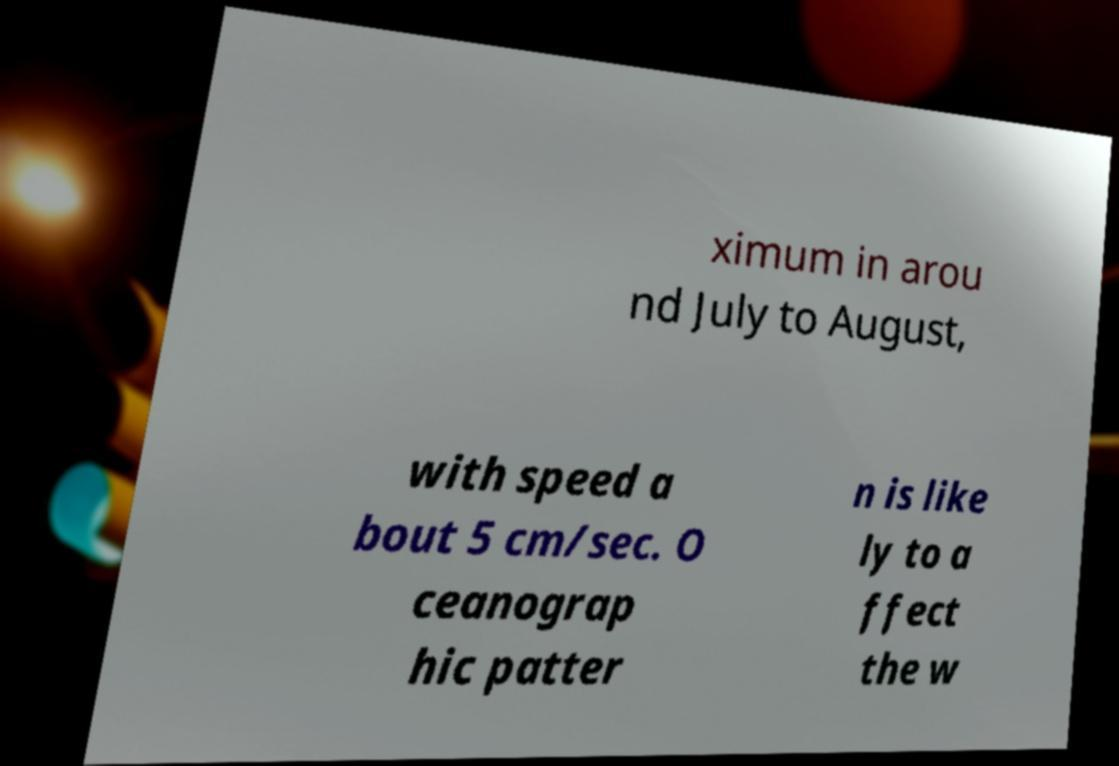Can you accurately transcribe the text from the provided image for me? ximum in arou nd July to August, with speed a bout 5 cm/sec. O ceanograp hic patter n is like ly to a ffect the w 